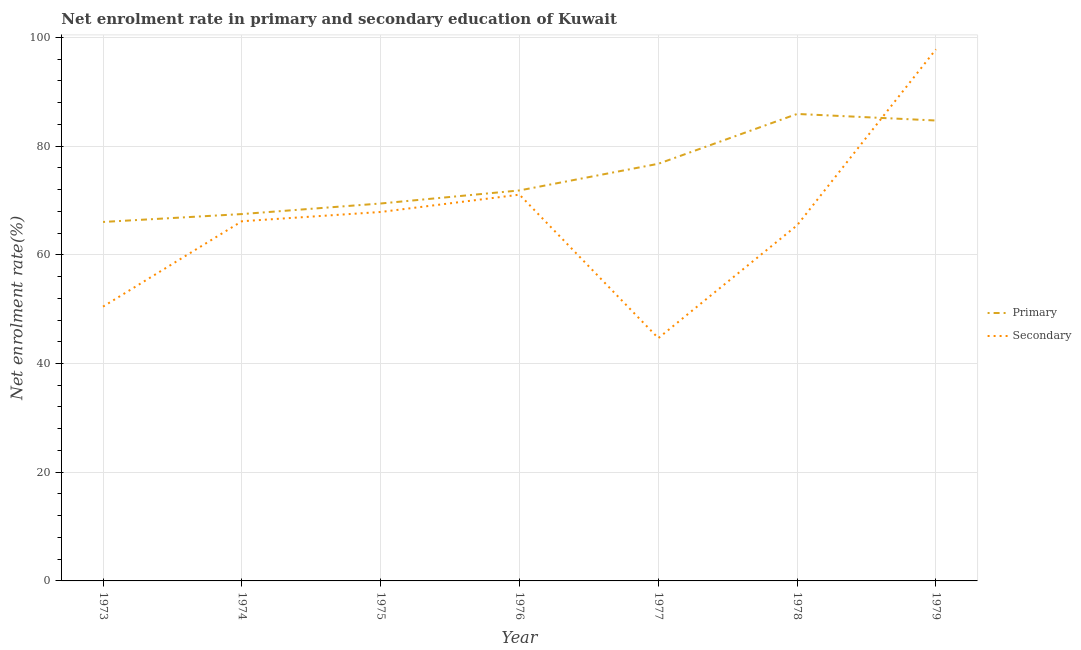Is the number of lines equal to the number of legend labels?
Make the answer very short. Yes. What is the enrollment rate in secondary education in 1978?
Keep it short and to the point. 65.43. Across all years, what is the maximum enrollment rate in primary education?
Your answer should be compact. 85.91. Across all years, what is the minimum enrollment rate in secondary education?
Keep it short and to the point. 44.66. In which year was the enrollment rate in primary education maximum?
Your answer should be very brief. 1978. In which year was the enrollment rate in secondary education minimum?
Offer a terse response. 1977. What is the total enrollment rate in primary education in the graph?
Your response must be concise. 522.19. What is the difference between the enrollment rate in secondary education in 1973 and that in 1978?
Your answer should be very brief. -14.96. What is the difference between the enrollment rate in primary education in 1978 and the enrollment rate in secondary education in 1977?
Keep it short and to the point. 41.25. What is the average enrollment rate in primary education per year?
Make the answer very short. 74.6. In the year 1978, what is the difference between the enrollment rate in primary education and enrollment rate in secondary education?
Keep it short and to the point. 20.48. In how many years, is the enrollment rate in secondary education greater than 64 %?
Give a very brief answer. 5. What is the ratio of the enrollment rate in secondary education in 1977 to that in 1979?
Offer a terse response. 0.46. Is the difference between the enrollment rate in primary education in 1975 and 1978 greater than the difference between the enrollment rate in secondary education in 1975 and 1978?
Offer a very short reply. No. What is the difference between the highest and the second highest enrollment rate in secondary education?
Keep it short and to the point. 26.74. What is the difference between the highest and the lowest enrollment rate in secondary education?
Your response must be concise. 53.14. In how many years, is the enrollment rate in primary education greater than the average enrollment rate in primary education taken over all years?
Give a very brief answer. 3. Is the sum of the enrollment rate in primary education in 1974 and 1975 greater than the maximum enrollment rate in secondary education across all years?
Your response must be concise. Yes. Is the enrollment rate in secondary education strictly greater than the enrollment rate in primary education over the years?
Your answer should be compact. No. What is the difference between two consecutive major ticks on the Y-axis?
Your response must be concise. 20. Are the values on the major ticks of Y-axis written in scientific E-notation?
Make the answer very short. No. Does the graph contain any zero values?
Provide a succinct answer. No. Does the graph contain grids?
Your answer should be very brief. Yes. How many legend labels are there?
Your answer should be compact. 2. How are the legend labels stacked?
Ensure brevity in your answer.  Vertical. What is the title of the graph?
Ensure brevity in your answer.  Net enrolment rate in primary and secondary education of Kuwait. What is the label or title of the Y-axis?
Provide a short and direct response. Net enrolment rate(%). What is the Net enrolment rate(%) of Primary in 1973?
Keep it short and to the point. 66.04. What is the Net enrolment rate(%) of Secondary in 1973?
Give a very brief answer. 50.47. What is the Net enrolment rate(%) in Primary in 1974?
Ensure brevity in your answer.  67.49. What is the Net enrolment rate(%) of Secondary in 1974?
Provide a short and direct response. 66.17. What is the Net enrolment rate(%) in Primary in 1975?
Your answer should be very brief. 69.44. What is the Net enrolment rate(%) in Secondary in 1975?
Make the answer very short. 67.88. What is the Net enrolment rate(%) in Primary in 1976?
Offer a terse response. 71.84. What is the Net enrolment rate(%) of Secondary in 1976?
Offer a terse response. 71.07. What is the Net enrolment rate(%) of Primary in 1977?
Make the answer very short. 76.75. What is the Net enrolment rate(%) in Secondary in 1977?
Your answer should be compact. 44.66. What is the Net enrolment rate(%) of Primary in 1978?
Ensure brevity in your answer.  85.91. What is the Net enrolment rate(%) in Secondary in 1978?
Make the answer very short. 65.43. What is the Net enrolment rate(%) in Primary in 1979?
Provide a short and direct response. 84.71. What is the Net enrolment rate(%) of Secondary in 1979?
Keep it short and to the point. 97.8. Across all years, what is the maximum Net enrolment rate(%) of Primary?
Provide a short and direct response. 85.91. Across all years, what is the maximum Net enrolment rate(%) of Secondary?
Provide a short and direct response. 97.8. Across all years, what is the minimum Net enrolment rate(%) in Primary?
Keep it short and to the point. 66.04. Across all years, what is the minimum Net enrolment rate(%) in Secondary?
Offer a very short reply. 44.66. What is the total Net enrolment rate(%) of Primary in the graph?
Offer a very short reply. 522.19. What is the total Net enrolment rate(%) of Secondary in the graph?
Ensure brevity in your answer.  463.48. What is the difference between the Net enrolment rate(%) of Primary in 1973 and that in 1974?
Your response must be concise. -1.45. What is the difference between the Net enrolment rate(%) in Secondary in 1973 and that in 1974?
Provide a succinct answer. -15.71. What is the difference between the Net enrolment rate(%) of Primary in 1973 and that in 1975?
Offer a very short reply. -3.4. What is the difference between the Net enrolment rate(%) in Secondary in 1973 and that in 1975?
Your response must be concise. -17.41. What is the difference between the Net enrolment rate(%) in Primary in 1973 and that in 1976?
Make the answer very short. -5.8. What is the difference between the Net enrolment rate(%) of Secondary in 1973 and that in 1976?
Provide a short and direct response. -20.6. What is the difference between the Net enrolment rate(%) in Primary in 1973 and that in 1977?
Your response must be concise. -10.7. What is the difference between the Net enrolment rate(%) of Secondary in 1973 and that in 1977?
Offer a terse response. 5.8. What is the difference between the Net enrolment rate(%) of Primary in 1973 and that in 1978?
Ensure brevity in your answer.  -19.87. What is the difference between the Net enrolment rate(%) in Secondary in 1973 and that in 1978?
Ensure brevity in your answer.  -14.96. What is the difference between the Net enrolment rate(%) in Primary in 1973 and that in 1979?
Keep it short and to the point. -18.66. What is the difference between the Net enrolment rate(%) in Secondary in 1973 and that in 1979?
Offer a very short reply. -47.34. What is the difference between the Net enrolment rate(%) in Primary in 1974 and that in 1975?
Ensure brevity in your answer.  -1.94. What is the difference between the Net enrolment rate(%) of Secondary in 1974 and that in 1975?
Your answer should be compact. -1.71. What is the difference between the Net enrolment rate(%) of Primary in 1974 and that in 1976?
Your answer should be very brief. -4.35. What is the difference between the Net enrolment rate(%) in Secondary in 1974 and that in 1976?
Your answer should be compact. -4.89. What is the difference between the Net enrolment rate(%) in Primary in 1974 and that in 1977?
Ensure brevity in your answer.  -9.25. What is the difference between the Net enrolment rate(%) of Secondary in 1974 and that in 1977?
Your answer should be compact. 21.51. What is the difference between the Net enrolment rate(%) of Primary in 1974 and that in 1978?
Your answer should be very brief. -18.42. What is the difference between the Net enrolment rate(%) in Secondary in 1974 and that in 1978?
Offer a terse response. 0.74. What is the difference between the Net enrolment rate(%) of Primary in 1974 and that in 1979?
Offer a very short reply. -17.21. What is the difference between the Net enrolment rate(%) in Secondary in 1974 and that in 1979?
Your response must be concise. -31.63. What is the difference between the Net enrolment rate(%) of Primary in 1975 and that in 1976?
Provide a succinct answer. -2.4. What is the difference between the Net enrolment rate(%) in Secondary in 1975 and that in 1976?
Your answer should be compact. -3.19. What is the difference between the Net enrolment rate(%) in Primary in 1975 and that in 1977?
Make the answer very short. -7.31. What is the difference between the Net enrolment rate(%) in Secondary in 1975 and that in 1977?
Your response must be concise. 23.22. What is the difference between the Net enrolment rate(%) in Primary in 1975 and that in 1978?
Your answer should be very brief. -16.48. What is the difference between the Net enrolment rate(%) of Secondary in 1975 and that in 1978?
Offer a very short reply. 2.45. What is the difference between the Net enrolment rate(%) of Primary in 1975 and that in 1979?
Your response must be concise. -15.27. What is the difference between the Net enrolment rate(%) in Secondary in 1975 and that in 1979?
Your answer should be very brief. -29.93. What is the difference between the Net enrolment rate(%) of Primary in 1976 and that in 1977?
Your response must be concise. -4.9. What is the difference between the Net enrolment rate(%) in Secondary in 1976 and that in 1977?
Provide a short and direct response. 26.4. What is the difference between the Net enrolment rate(%) in Primary in 1976 and that in 1978?
Make the answer very short. -14.07. What is the difference between the Net enrolment rate(%) of Secondary in 1976 and that in 1978?
Offer a very short reply. 5.63. What is the difference between the Net enrolment rate(%) of Primary in 1976 and that in 1979?
Offer a terse response. -12.86. What is the difference between the Net enrolment rate(%) of Secondary in 1976 and that in 1979?
Make the answer very short. -26.74. What is the difference between the Net enrolment rate(%) of Primary in 1977 and that in 1978?
Keep it short and to the point. -9.17. What is the difference between the Net enrolment rate(%) in Secondary in 1977 and that in 1978?
Give a very brief answer. -20.77. What is the difference between the Net enrolment rate(%) in Primary in 1977 and that in 1979?
Make the answer very short. -7.96. What is the difference between the Net enrolment rate(%) of Secondary in 1977 and that in 1979?
Offer a terse response. -53.14. What is the difference between the Net enrolment rate(%) in Primary in 1978 and that in 1979?
Provide a short and direct response. 1.21. What is the difference between the Net enrolment rate(%) in Secondary in 1978 and that in 1979?
Provide a succinct answer. -32.37. What is the difference between the Net enrolment rate(%) in Primary in 1973 and the Net enrolment rate(%) in Secondary in 1974?
Your answer should be very brief. -0.13. What is the difference between the Net enrolment rate(%) of Primary in 1973 and the Net enrolment rate(%) of Secondary in 1975?
Your answer should be compact. -1.84. What is the difference between the Net enrolment rate(%) of Primary in 1973 and the Net enrolment rate(%) of Secondary in 1976?
Offer a very short reply. -5.02. What is the difference between the Net enrolment rate(%) of Primary in 1973 and the Net enrolment rate(%) of Secondary in 1977?
Offer a very short reply. 21.38. What is the difference between the Net enrolment rate(%) in Primary in 1973 and the Net enrolment rate(%) in Secondary in 1978?
Your response must be concise. 0.61. What is the difference between the Net enrolment rate(%) in Primary in 1973 and the Net enrolment rate(%) in Secondary in 1979?
Offer a very short reply. -31.76. What is the difference between the Net enrolment rate(%) of Primary in 1974 and the Net enrolment rate(%) of Secondary in 1975?
Your answer should be very brief. -0.38. What is the difference between the Net enrolment rate(%) in Primary in 1974 and the Net enrolment rate(%) in Secondary in 1976?
Your answer should be very brief. -3.57. What is the difference between the Net enrolment rate(%) of Primary in 1974 and the Net enrolment rate(%) of Secondary in 1977?
Offer a very short reply. 22.83. What is the difference between the Net enrolment rate(%) in Primary in 1974 and the Net enrolment rate(%) in Secondary in 1978?
Keep it short and to the point. 2.06. What is the difference between the Net enrolment rate(%) of Primary in 1974 and the Net enrolment rate(%) of Secondary in 1979?
Provide a succinct answer. -30.31. What is the difference between the Net enrolment rate(%) in Primary in 1975 and the Net enrolment rate(%) in Secondary in 1976?
Ensure brevity in your answer.  -1.63. What is the difference between the Net enrolment rate(%) of Primary in 1975 and the Net enrolment rate(%) of Secondary in 1977?
Your response must be concise. 24.78. What is the difference between the Net enrolment rate(%) of Primary in 1975 and the Net enrolment rate(%) of Secondary in 1978?
Your response must be concise. 4.01. What is the difference between the Net enrolment rate(%) of Primary in 1975 and the Net enrolment rate(%) of Secondary in 1979?
Give a very brief answer. -28.36. What is the difference between the Net enrolment rate(%) in Primary in 1976 and the Net enrolment rate(%) in Secondary in 1977?
Provide a succinct answer. 27.18. What is the difference between the Net enrolment rate(%) of Primary in 1976 and the Net enrolment rate(%) of Secondary in 1978?
Your answer should be compact. 6.41. What is the difference between the Net enrolment rate(%) of Primary in 1976 and the Net enrolment rate(%) of Secondary in 1979?
Keep it short and to the point. -25.96. What is the difference between the Net enrolment rate(%) in Primary in 1977 and the Net enrolment rate(%) in Secondary in 1978?
Your answer should be compact. 11.31. What is the difference between the Net enrolment rate(%) in Primary in 1977 and the Net enrolment rate(%) in Secondary in 1979?
Offer a terse response. -21.06. What is the difference between the Net enrolment rate(%) in Primary in 1978 and the Net enrolment rate(%) in Secondary in 1979?
Keep it short and to the point. -11.89. What is the average Net enrolment rate(%) in Primary per year?
Give a very brief answer. 74.6. What is the average Net enrolment rate(%) in Secondary per year?
Your answer should be compact. 66.21. In the year 1973, what is the difference between the Net enrolment rate(%) of Primary and Net enrolment rate(%) of Secondary?
Ensure brevity in your answer.  15.57. In the year 1974, what is the difference between the Net enrolment rate(%) of Primary and Net enrolment rate(%) of Secondary?
Your answer should be very brief. 1.32. In the year 1975, what is the difference between the Net enrolment rate(%) in Primary and Net enrolment rate(%) in Secondary?
Offer a terse response. 1.56. In the year 1976, what is the difference between the Net enrolment rate(%) in Primary and Net enrolment rate(%) in Secondary?
Ensure brevity in your answer.  0.78. In the year 1977, what is the difference between the Net enrolment rate(%) in Primary and Net enrolment rate(%) in Secondary?
Make the answer very short. 32.08. In the year 1978, what is the difference between the Net enrolment rate(%) of Primary and Net enrolment rate(%) of Secondary?
Give a very brief answer. 20.48. In the year 1979, what is the difference between the Net enrolment rate(%) in Primary and Net enrolment rate(%) in Secondary?
Make the answer very short. -13.1. What is the ratio of the Net enrolment rate(%) in Primary in 1973 to that in 1974?
Provide a succinct answer. 0.98. What is the ratio of the Net enrolment rate(%) of Secondary in 1973 to that in 1974?
Offer a very short reply. 0.76. What is the ratio of the Net enrolment rate(%) of Primary in 1973 to that in 1975?
Your response must be concise. 0.95. What is the ratio of the Net enrolment rate(%) in Secondary in 1973 to that in 1975?
Your answer should be compact. 0.74. What is the ratio of the Net enrolment rate(%) in Primary in 1973 to that in 1976?
Offer a terse response. 0.92. What is the ratio of the Net enrolment rate(%) in Secondary in 1973 to that in 1976?
Offer a very short reply. 0.71. What is the ratio of the Net enrolment rate(%) in Primary in 1973 to that in 1977?
Keep it short and to the point. 0.86. What is the ratio of the Net enrolment rate(%) of Secondary in 1973 to that in 1977?
Ensure brevity in your answer.  1.13. What is the ratio of the Net enrolment rate(%) of Primary in 1973 to that in 1978?
Keep it short and to the point. 0.77. What is the ratio of the Net enrolment rate(%) of Secondary in 1973 to that in 1978?
Your answer should be compact. 0.77. What is the ratio of the Net enrolment rate(%) of Primary in 1973 to that in 1979?
Your answer should be very brief. 0.78. What is the ratio of the Net enrolment rate(%) of Secondary in 1973 to that in 1979?
Offer a terse response. 0.52. What is the ratio of the Net enrolment rate(%) in Secondary in 1974 to that in 1975?
Your response must be concise. 0.97. What is the ratio of the Net enrolment rate(%) of Primary in 1974 to that in 1976?
Offer a terse response. 0.94. What is the ratio of the Net enrolment rate(%) of Secondary in 1974 to that in 1976?
Provide a short and direct response. 0.93. What is the ratio of the Net enrolment rate(%) in Primary in 1974 to that in 1977?
Offer a terse response. 0.88. What is the ratio of the Net enrolment rate(%) in Secondary in 1974 to that in 1977?
Make the answer very short. 1.48. What is the ratio of the Net enrolment rate(%) of Primary in 1974 to that in 1978?
Provide a succinct answer. 0.79. What is the ratio of the Net enrolment rate(%) of Secondary in 1974 to that in 1978?
Make the answer very short. 1.01. What is the ratio of the Net enrolment rate(%) in Primary in 1974 to that in 1979?
Provide a succinct answer. 0.8. What is the ratio of the Net enrolment rate(%) of Secondary in 1974 to that in 1979?
Your answer should be compact. 0.68. What is the ratio of the Net enrolment rate(%) of Primary in 1975 to that in 1976?
Your answer should be compact. 0.97. What is the ratio of the Net enrolment rate(%) of Secondary in 1975 to that in 1976?
Ensure brevity in your answer.  0.96. What is the ratio of the Net enrolment rate(%) in Primary in 1975 to that in 1977?
Offer a terse response. 0.9. What is the ratio of the Net enrolment rate(%) of Secondary in 1975 to that in 1977?
Give a very brief answer. 1.52. What is the ratio of the Net enrolment rate(%) of Primary in 1975 to that in 1978?
Offer a very short reply. 0.81. What is the ratio of the Net enrolment rate(%) of Secondary in 1975 to that in 1978?
Your answer should be very brief. 1.04. What is the ratio of the Net enrolment rate(%) in Primary in 1975 to that in 1979?
Your answer should be compact. 0.82. What is the ratio of the Net enrolment rate(%) in Secondary in 1975 to that in 1979?
Ensure brevity in your answer.  0.69. What is the ratio of the Net enrolment rate(%) of Primary in 1976 to that in 1977?
Your answer should be compact. 0.94. What is the ratio of the Net enrolment rate(%) in Secondary in 1976 to that in 1977?
Your answer should be compact. 1.59. What is the ratio of the Net enrolment rate(%) of Primary in 1976 to that in 1978?
Your answer should be compact. 0.84. What is the ratio of the Net enrolment rate(%) of Secondary in 1976 to that in 1978?
Offer a terse response. 1.09. What is the ratio of the Net enrolment rate(%) of Primary in 1976 to that in 1979?
Your answer should be compact. 0.85. What is the ratio of the Net enrolment rate(%) of Secondary in 1976 to that in 1979?
Provide a short and direct response. 0.73. What is the ratio of the Net enrolment rate(%) of Primary in 1977 to that in 1978?
Offer a very short reply. 0.89. What is the ratio of the Net enrolment rate(%) of Secondary in 1977 to that in 1978?
Give a very brief answer. 0.68. What is the ratio of the Net enrolment rate(%) of Primary in 1977 to that in 1979?
Make the answer very short. 0.91. What is the ratio of the Net enrolment rate(%) in Secondary in 1977 to that in 1979?
Your answer should be very brief. 0.46. What is the ratio of the Net enrolment rate(%) of Primary in 1978 to that in 1979?
Provide a succinct answer. 1.01. What is the ratio of the Net enrolment rate(%) in Secondary in 1978 to that in 1979?
Your response must be concise. 0.67. What is the difference between the highest and the second highest Net enrolment rate(%) of Primary?
Your response must be concise. 1.21. What is the difference between the highest and the second highest Net enrolment rate(%) in Secondary?
Ensure brevity in your answer.  26.74. What is the difference between the highest and the lowest Net enrolment rate(%) of Primary?
Your answer should be compact. 19.87. What is the difference between the highest and the lowest Net enrolment rate(%) of Secondary?
Provide a succinct answer. 53.14. 